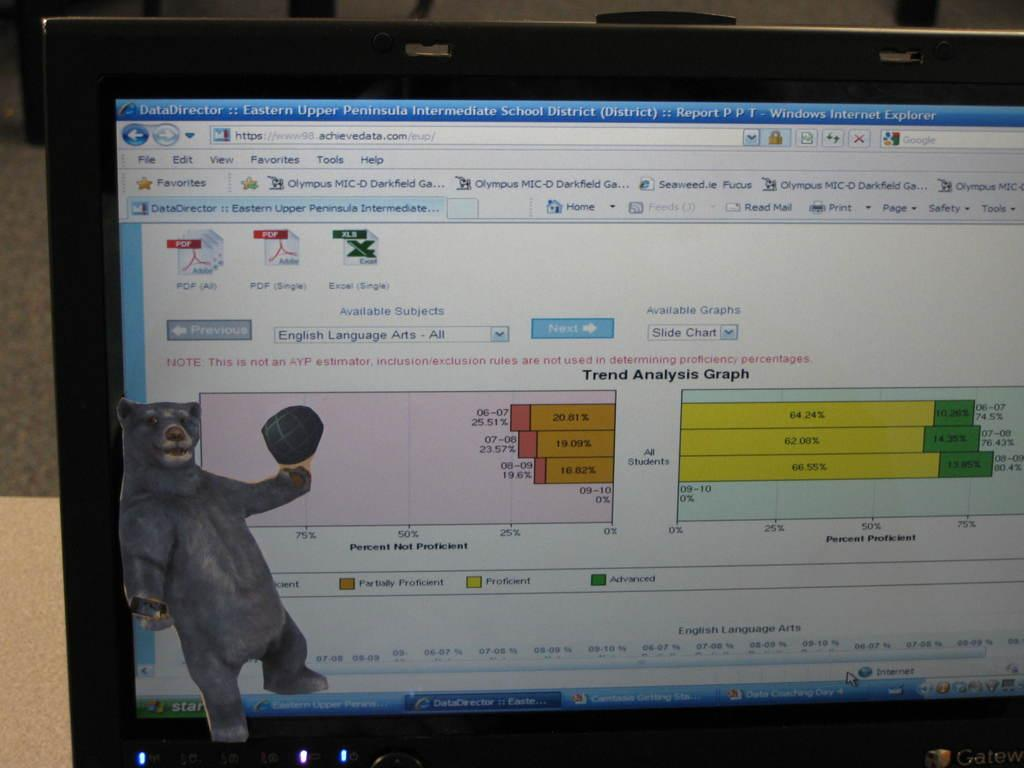<image>
Share a concise interpretation of the image provided. The upper left corner of a computer screen gives the name of the program, Data Director.. 